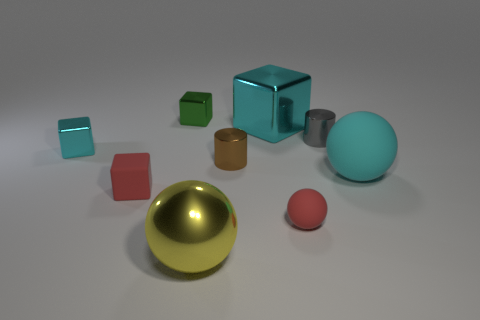Is the number of tiny gray metal things less than the number of small blocks?
Your response must be concise. Yes. The block that is on the right side of the rubber block and left of the big metallic block is made of what material?
Keep it short and to the point. Metal. What size is the shiny cylinder that is left of the large cyan thing that is behind the small cylinder that is in front of the gray object?
Your answer should be very brief. Small. Does the small brown shiny object have the same shape as the object behind the large shiny block?
Keep it short and to the point. No. What number of tiny blocks are both in front of the tiny cyan object and to the right of the red matte cube?
Provide a succinct answer. 0. What number of cyan objects are either large cubes or tiny balls?
Offer a terse response. 1. Is the color of the tiny block that is in front of the tiny brown cylinder the same as the matte object that is in front of the red matte cube?
Ensure brevity in your answer.  Yes. There is a large metallic object in front of the metallic cube on the left side of the tiny red thing that is left of the small brown thing; what is its color?
Give a very brief answer. Yellow. There is a big cyan thing that is behind the gray shiny thing; is there a metallic ball that is to the right of it?
Keep it short and to the point. No. There is a matte thing to the right of the tiny gray shiny cylinder; is its shape the same as the small cyan thing?
Keep it short and to the point. No. 